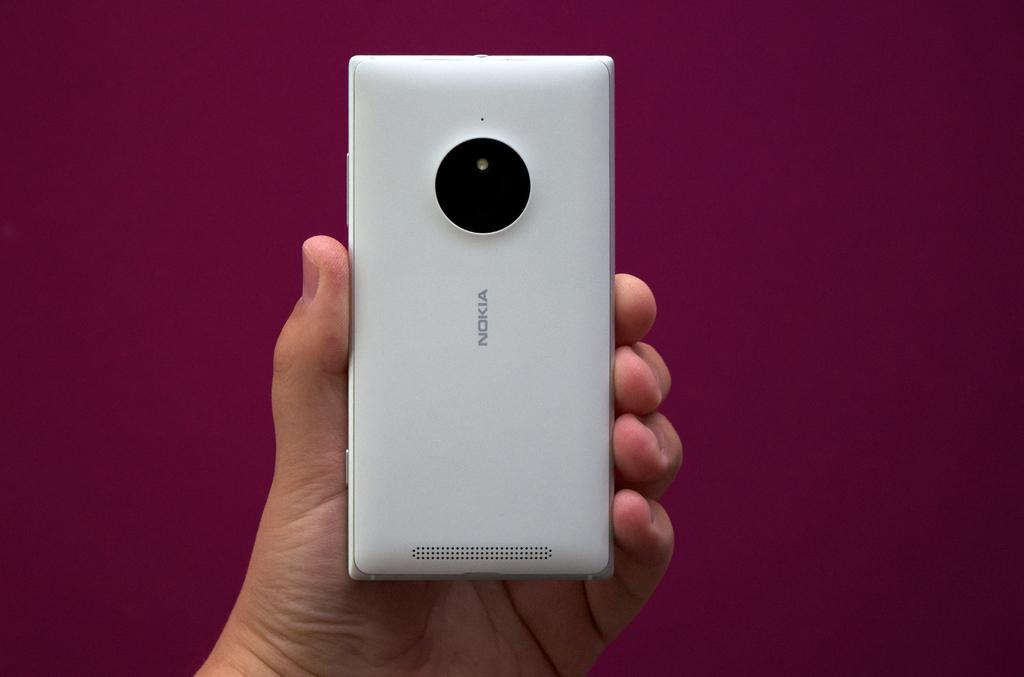<image>
Give a short and clear explanation of the subsequent image. A white Nokia phone with a large camera. 